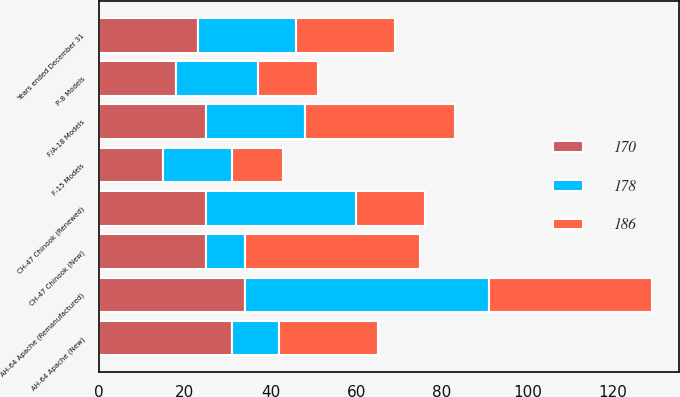Convert chart to OTSL. <chart><loc_0><loc_0><loc_500><loc_500><stacked_bar_chart><ecel><fcel>Years ended December 31<fcel>F/A-18 Models<fcel>F-15 Models<fcel>CH-47 Chinook (New)<fcel>CH-47 Chinook (Renewed)<fcel>AH-64 Apache (New)<fcel>AH-64 Apache (Remanufactured)<fcel>P-8 Models<nl><fcel>178<fcel>23<fcel>23<fcel>16<fcel>9<fcel>35<fcel>11<fcel>57<fcel>19<nl><fcel>170<fcel>23<fcel>25<fcel>15<fcel>25<fcel>25<fcel>31<fcel>34<fcel>18<nl><fcel>186<fcel>23<fcel>35<fcel>12<fcel>41<fcel>16<fcel>23<fcel>38<fcel>14<nl></chart> 